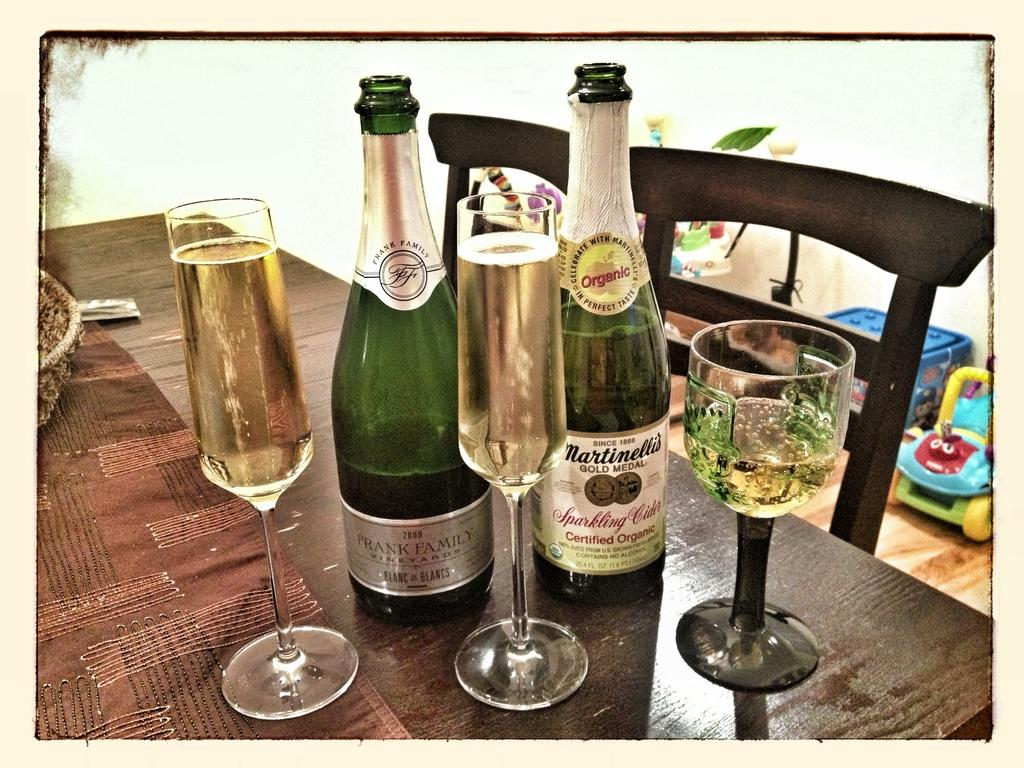What is covering the table in the image? There is a cloth on the table. What objects are on the table? There are glasses and bottles on the table. What piece of furniture is beside the table? There is a chair beside the table. What is on the floor in the image? There is a toy car on the floor and a basket on the floor. How many lizards are crawling on the desk in the image? There is no desk present in the image, and no lizards are visible. What color is the hair on the person in the image? There is no person visible in the image, so we cannot determine the color of their hair. 